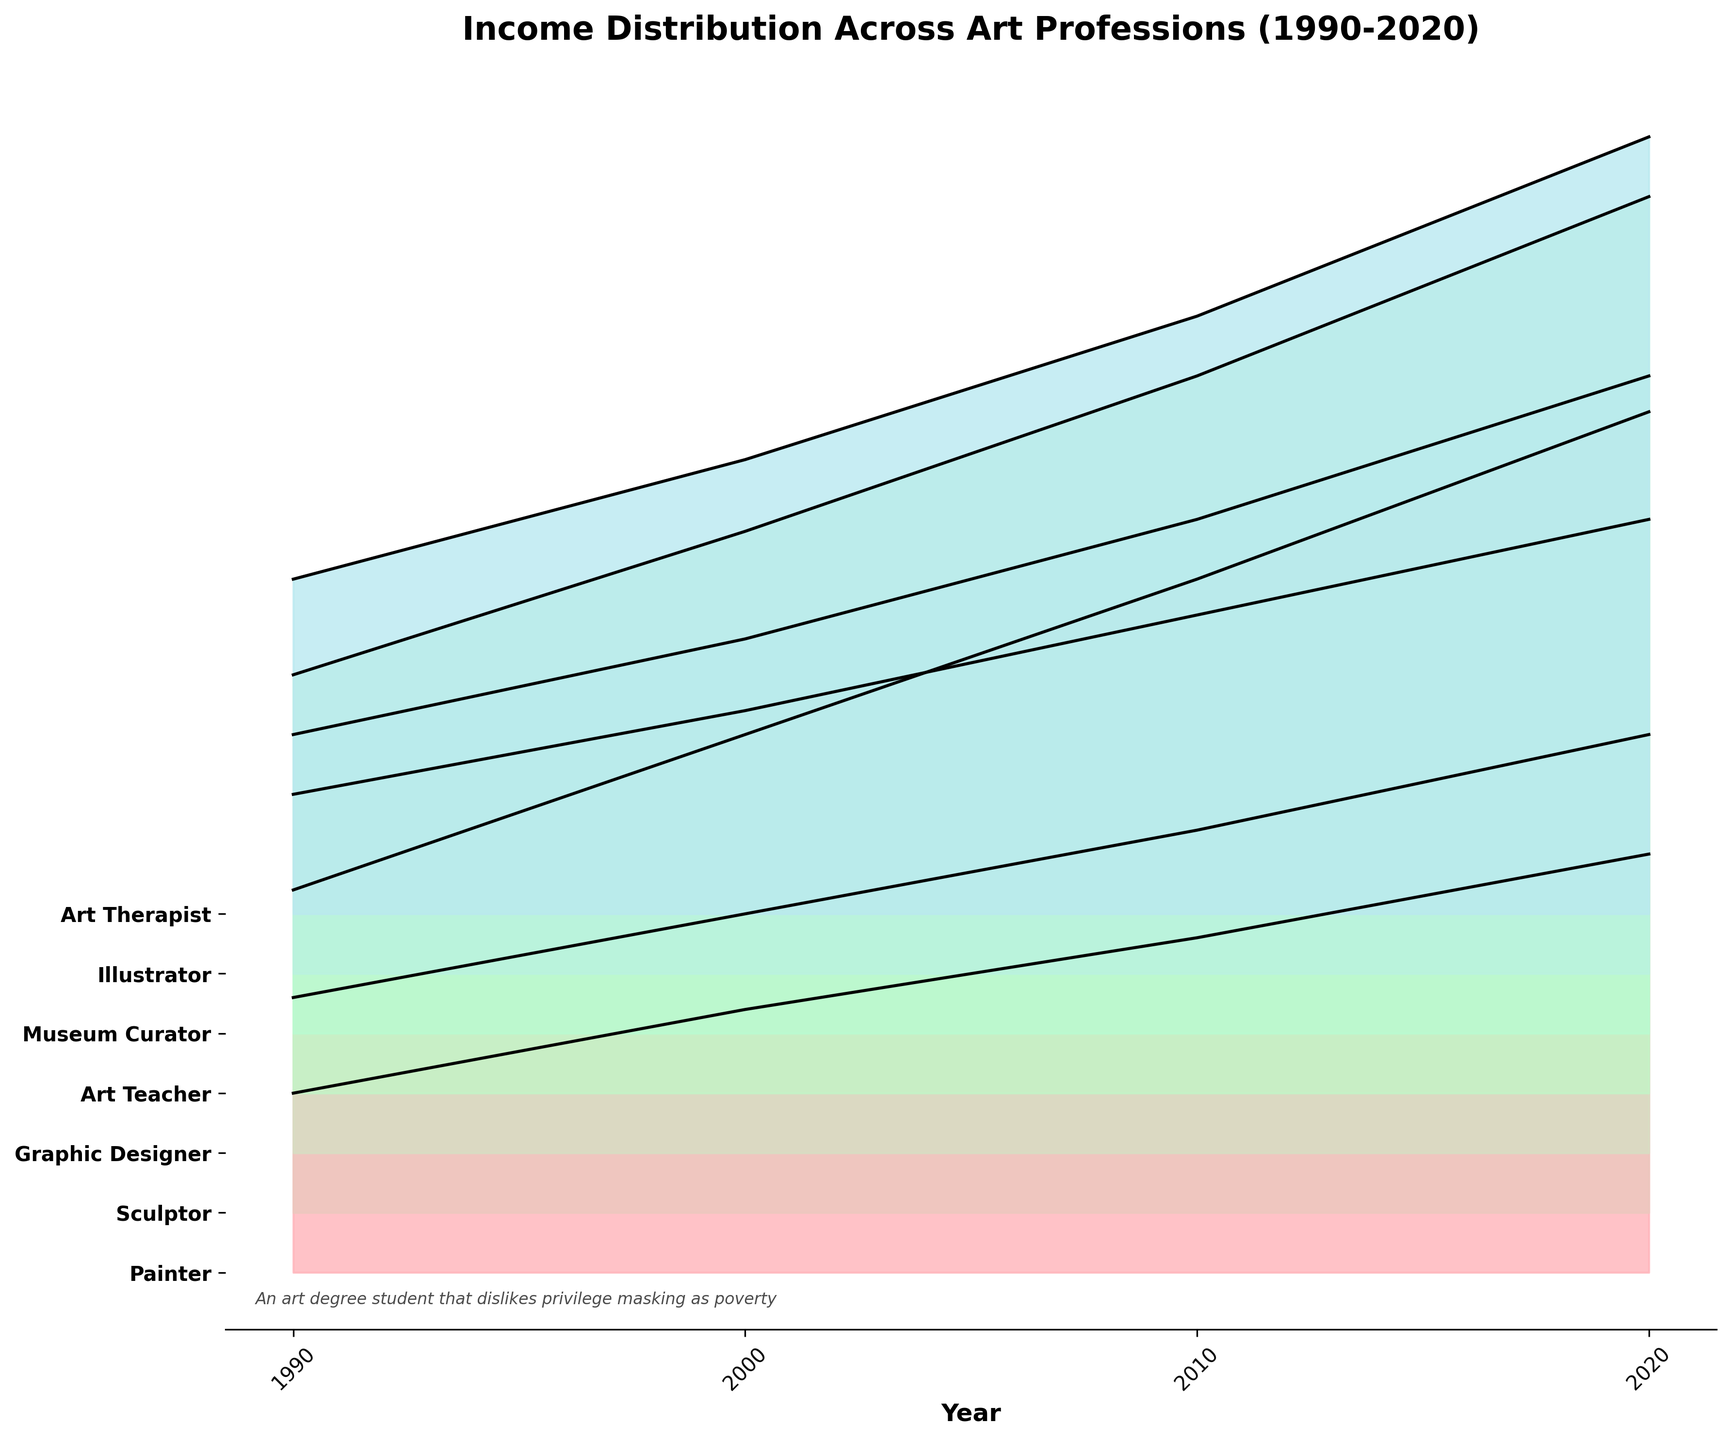What are the professions listed in the figure? There are multiple colored ridgelines each representing a different profession. The y-axis labels show the names of these professions. They include Painter, Sculptor, Graphic Designer, Art Teacher, Museum Curator, Illustrator, and Art Therapist.
Answer: Painter, Sculptor, Graphic Designer, Art Teacher, Museum Curator, Illustrator, Art Therapist What is the title of the figure? The title is located at the top of the figure, usually in a larger and bold font to stand out. It succinctly describes what the plot is about.
Answer: Income Distribution Across Art Professions (1990-2020) What was the income trend for "Sculptor" from 1990 to 2020? By examining the ridgeline for Sculptor from left (1990) to right (2020), it is clear that there is a steady upward trend. The income increases from $18,000 in 1990 to $40,000 in 2020.
Answer: Increasing Which profession had the highest income in 2020? Locate the year 2020 on the x-axis and observe the heights of ridgelines for each profession. The one reaching the highest point represents the highest income.
Answer: Museum Curator In which year did "Graphic Designer" see the sharpest increase in income? Observing the ridgeline for Graphic Designer, the income increase is greatest between two adjacent points. The largest jump in height occurs between the years 1990 and 2000.
Answer: Between 1990 and 2000 Which profession has the most consistent income growth over the years? Consistent growth is seen where the ridgeline uniformly rises without sharp jumps or drops. By observing all ridgelines, Art Teacher shows a steady and consistent rise in income from 1990 to 2020.
Answer: Art Teacher How many data points are there for each profession? Each profession has evenly spaced data points along the time axis representing different years. For each profession, there are data points for 1990, 2000, 2010, and 2020.
Answer: 4 What is the income difference between "Painter" and "Graphic Designer" in 2020? Locate the year 2020 on the x-axis and compare the heights of the ridgelines for Painter and Graphic Designer. The income for Painter is $35,000 and for Graphic Designer is $62,000, hence the difference is $62,000 - $35,000.
Answer: $27,000 Which profession had the lowest income in 1990, and what was it? Locate the year 1990 on the x-axis and check the heights of the ridgelines for each profession. The lowest one represents the lowest income.
Answer: Painter, $15,000 